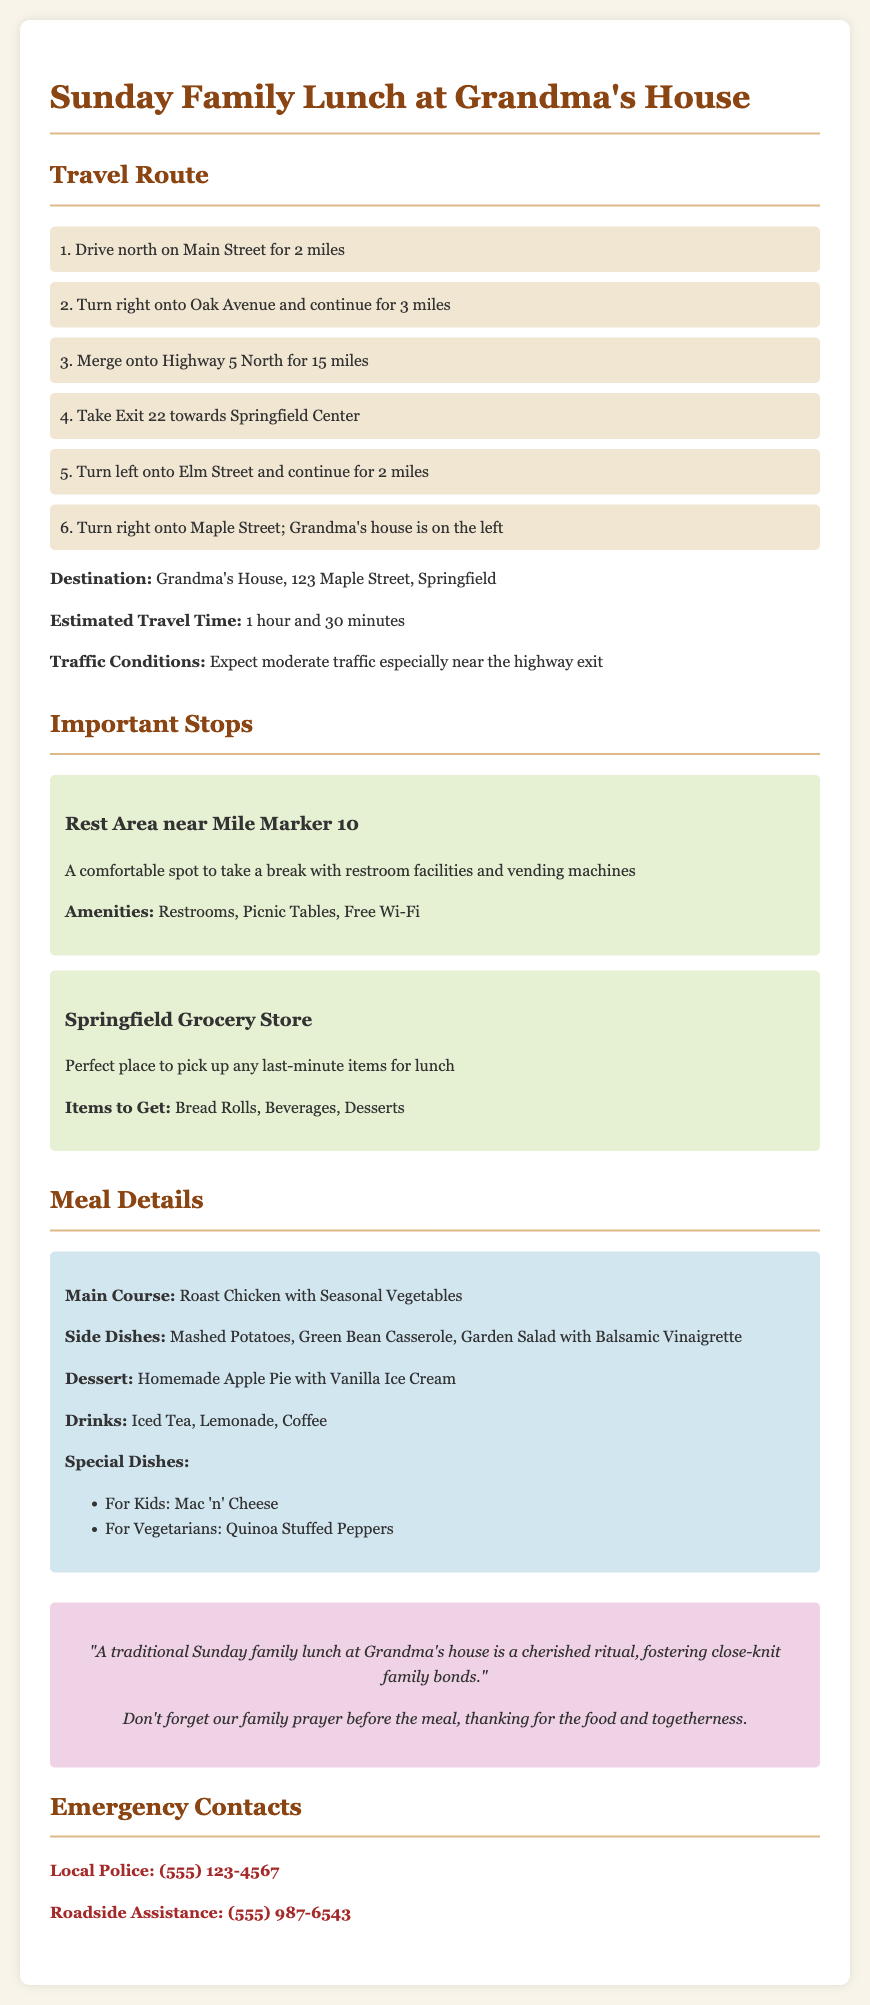what is the location of Grandma's house? The document provides the specific address for Grandma's house, which is located at 123 Maple Street, Springfield.
Answer: 123 Maple Street, Springfield how long is the estimated travel time? The document states the estimated travel time to Grandma's house, which is 1 hour and 30 minutes.
Answer: 1 hour and 30 minutes what is the main course for lunch? The document specifies the main dish being served for lunch, which is roast chicken with seasonal vegetables.
Answer: Roast Chicken with Seasonal Vegetables what are the special dishes for kids? The document mentions a specific dish made especially for kids, which is mac 'n' cheese.
Answer: Mac 'n' Cheese what amenities are available at the rest area? The document lists the facilities available at the rest area, which includes restrooms, picnic tables, and free Wi-Fi.
Answer: Restrooms, Picnic Tables, Free Wi-Fi how many miles is the drive on Main Street? The distance mentioned in the travel route for driving north on Main Street is 2 miles.
Answer: 2 miles what is the significant family ritual mentioned before the meal? The document mentions an important family practice that occurs before the meal, specifically that they say a prayer.
Answer: Family prayer where can last-minute items for lunch be picked up? The document indicates that the Springfield Grocery Store is the place for picking up last-minute lunch items.
Answer: Springfield Grocery Store 